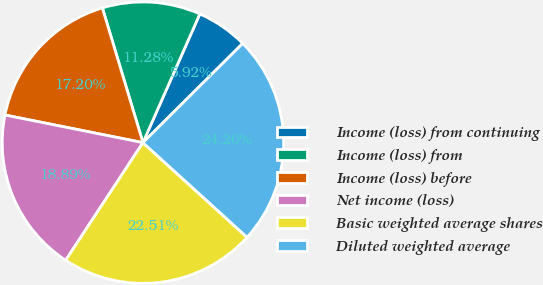<chart> <loc_0><loc_0><loc_500><loc_500><pie_chart><fcel>Income (loss) from continuing<fcel>Income (loss) from<fcel>Income (loss) before<fcel>Net income (loss)<fcel>Basic weighted average shares<fcel>Diluted weighted average<nl><fcel>5.92%<fcel>11.28%<fcel>17.2%<fcel>18.89%<fcel>22.51%<fcel>24.2%<nl></chart> 